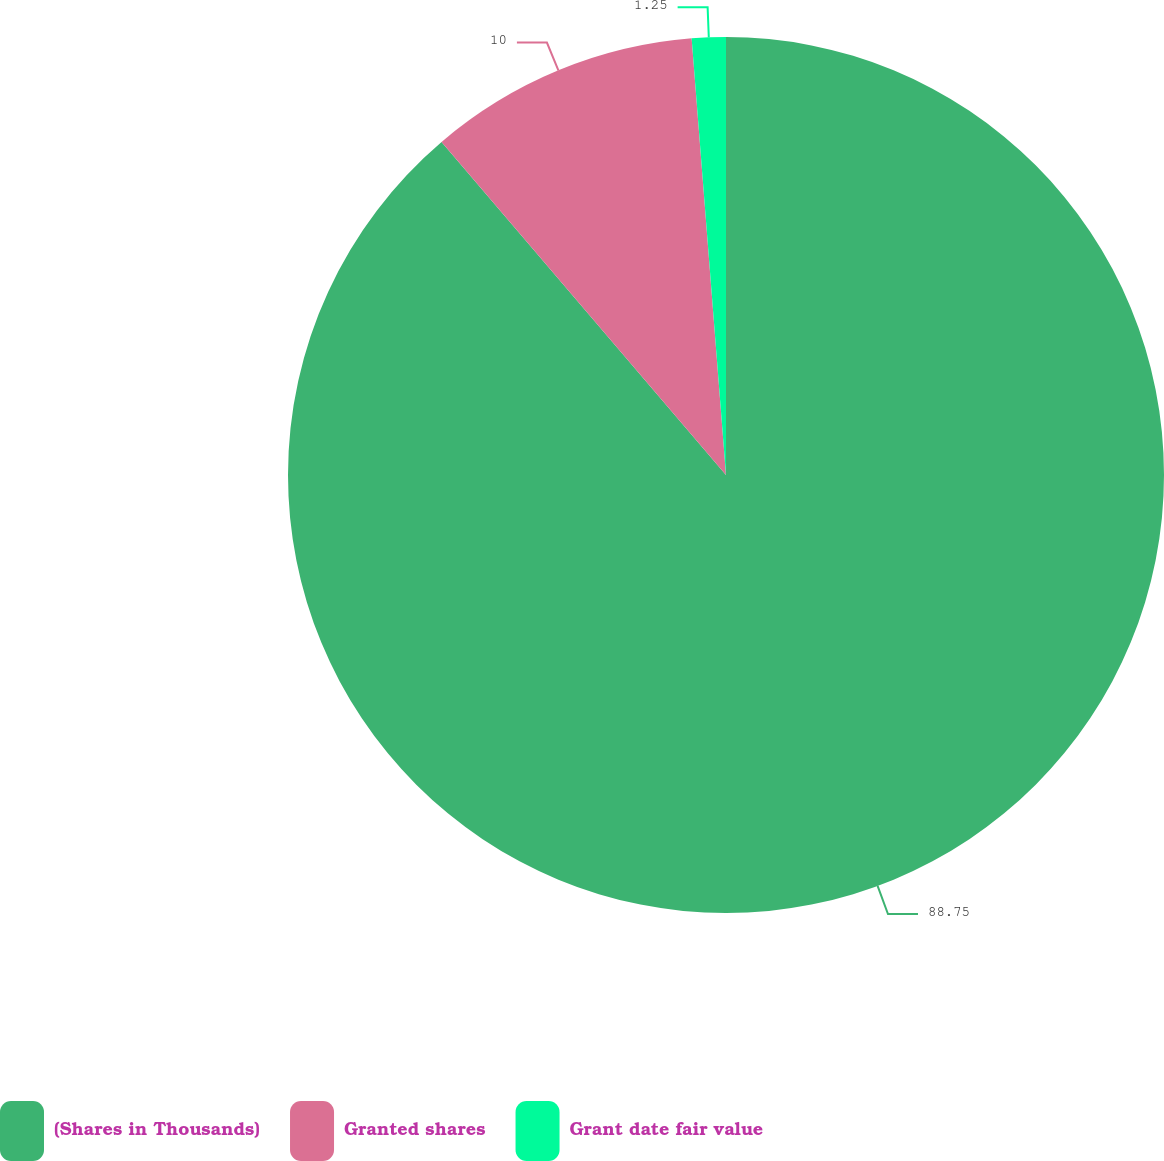Convert chart. <chart><loc_0><loc_0><loc_500><loc_500><pie_chart><fcel>(Shares in Thousands)<fcel>Granted shares<fcel>Grant date fair value<nl><fcel>88.75%<fcel>10.0%<fcel>1.25%<nl></chart> 